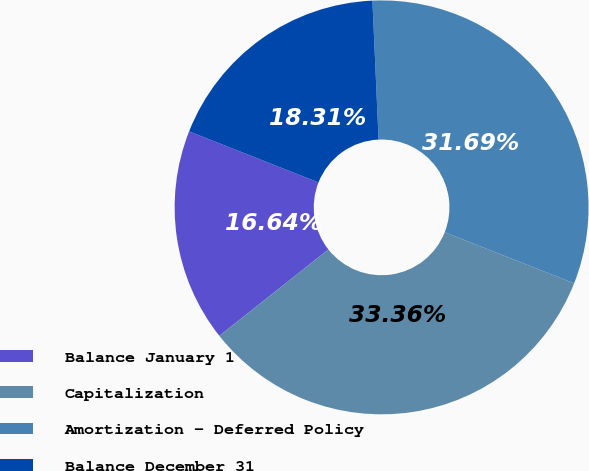Convert chart to OTSL. <chart><loc_0><loc_0><loc_500><loc_500><pie_chart><fcel>Balance January 1<fcel>Capitalization<fcel>Amortization - Deferred Policy<fcel>Balance December 31<nl><fcel>16.64%<fcel>33.36%<fcel>31.69%<fcel>18.31%<nl></chart> 